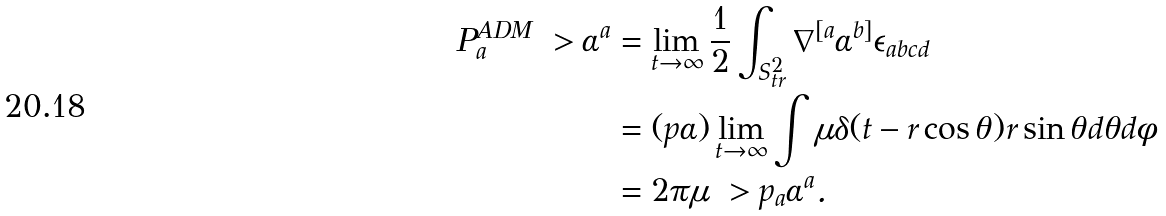Convert formula to latex. <formula><loc_0><loc_0><loc_500><loc_500>P ^ { A D M } _ { a } \ > \alpha ^ { a } & = \lim _ { t \to \infty } \frac { 1 } { 2 } \int _ { S ^ { 2 } _ { t r } } \nabla ^ { [ a } \alpha ^ { b ] } \epsilon _ { a b c d } \\ & = ( p \alpha ) \lim _ { t \to \infty } \int \mu \delta ( t - r \cos \theta ) r \sin \theta d \theta d \phi \\ & = 2 \pi \mu \ > p _ { a } \alpha ^ { a } .</formula> 